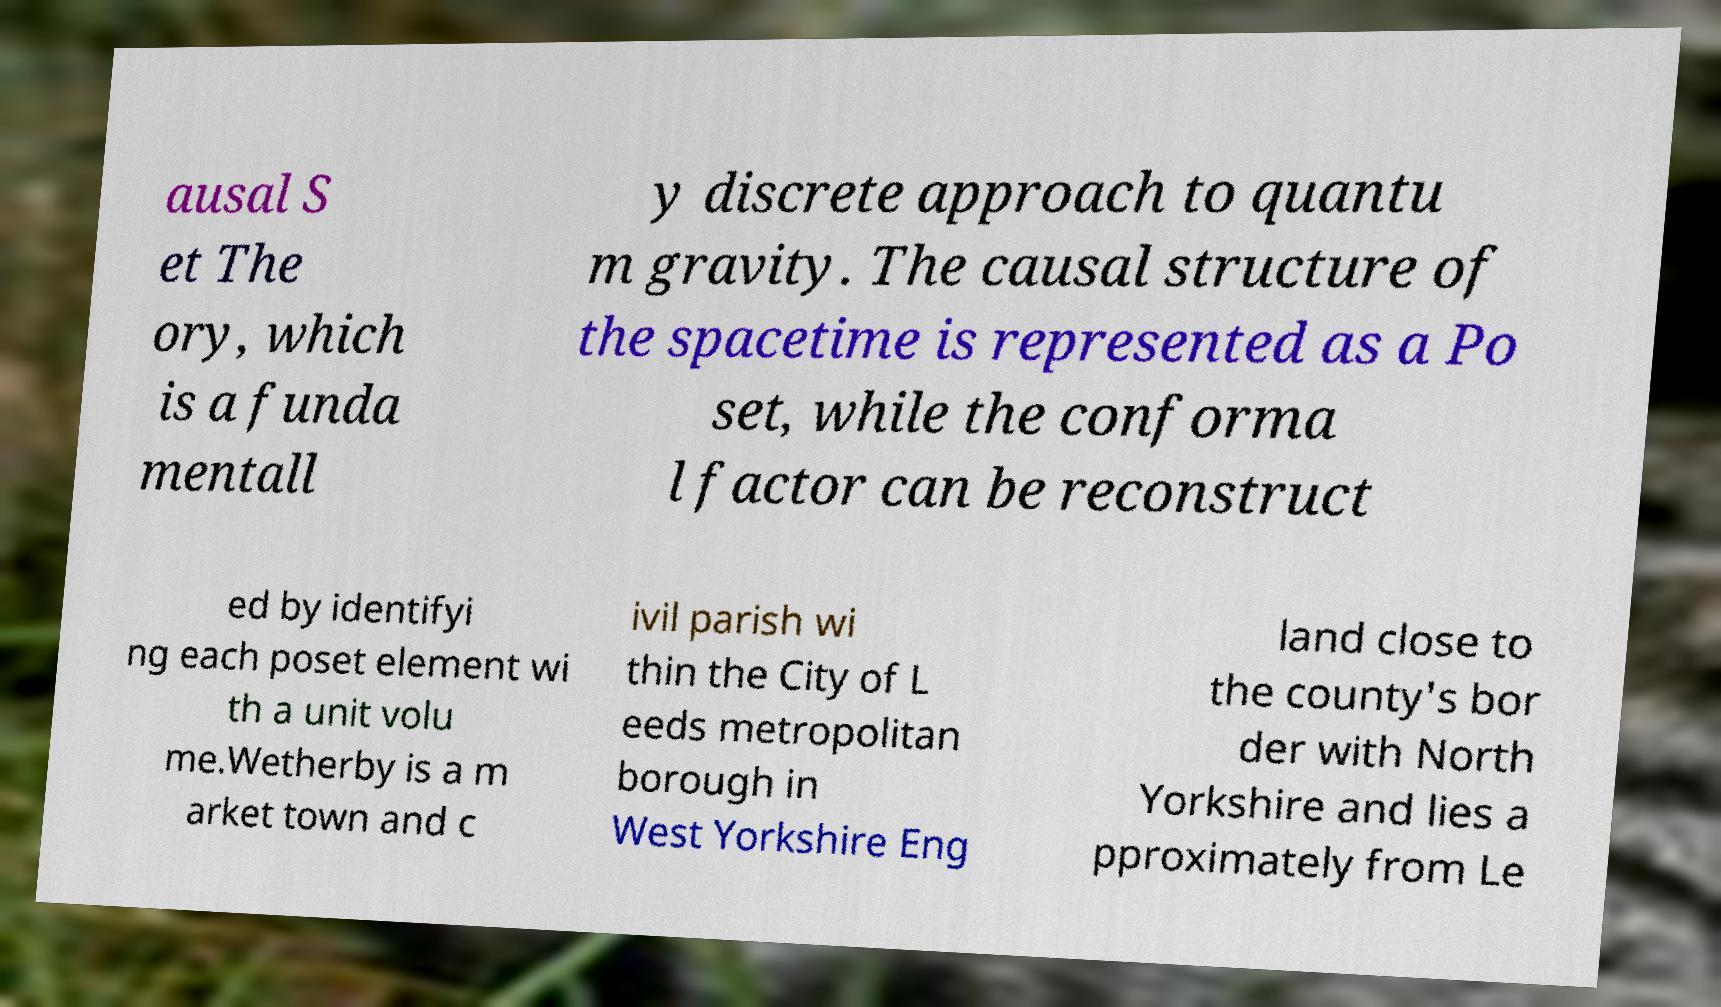Can you read and provide the text displayed in the image?This photo seems to have some interesting text. Can you extract and type it out for me? ausal S et The ory, which is a funda mentall y discrete approach to quantu m gravity. The causal structure of the spacetime is represented as a Po set, while the conforma l factor can be reconstruct ed by identifyi ng each poset element wi th a unit volu me.Wetherby is a m arket town and c ivil parish wi thin the City of L eeds metropolitan borough in West Yorkshire Eng land close to the county's bor der with North Yorkshire and lies a pproximately from Le 